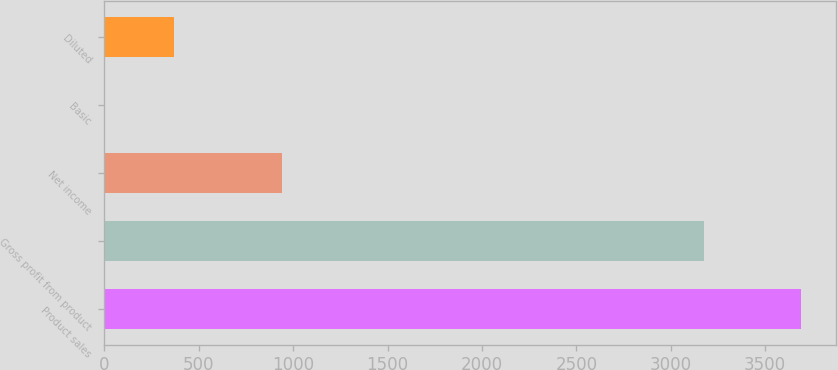<chart> <loc_0><loc_0><loc_500><loc_500><bar_chart><fcel>Product sales<fcel>Gross profit from product<fcel>Net income<fcel>Basic<fcel>Diluted<nl><fcel>3692<fcel>3177<fcel>941<fcel>0.87<fcel>369.98<nl></chart> 